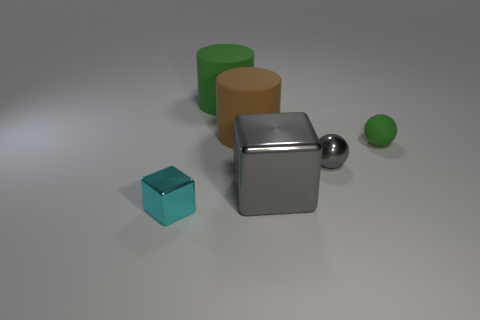What shape is the big green rubber thing?
Your response must be concise. Cylinder. Is there any other thing that is the same color as the large block?
Ensure brevity in your answer.  Yes. Is the size of the gray thing left of the gray metallic sphere the same as the block that is to the left of the big green rubber object?
Offer a very short reply. No. What is the shape of the green object that is to the left of the small metallic thing that is behind the cyan thing?
Give a very brief answer. Cylinder. Do the cyan block and the gray metallic thing behind the big cube have the same size?
Your answer should be very brief. Yes. How big is the metal thing that is in front of the gray metallic thing left of the shiny object that is right of the gray block?
Your answer should be very brief. Small. How many things are green matte objects that are behind the large brown rubber cylinder or purple cylinders?
Make the answer very short. 1. There is a small shiny thing behind the small cyan metallic object; what number of tiny cyan things are behind it?
Your answer should be very brief. 0. Is the number of large cubes left of the big brown thing greater than the number of gray cubes?
Give a very brief answer. No. What size is the object that is on the left side of the large brown rubber cylinder and behind the small cyan shiny block?
Your answer should be compact. Large. 